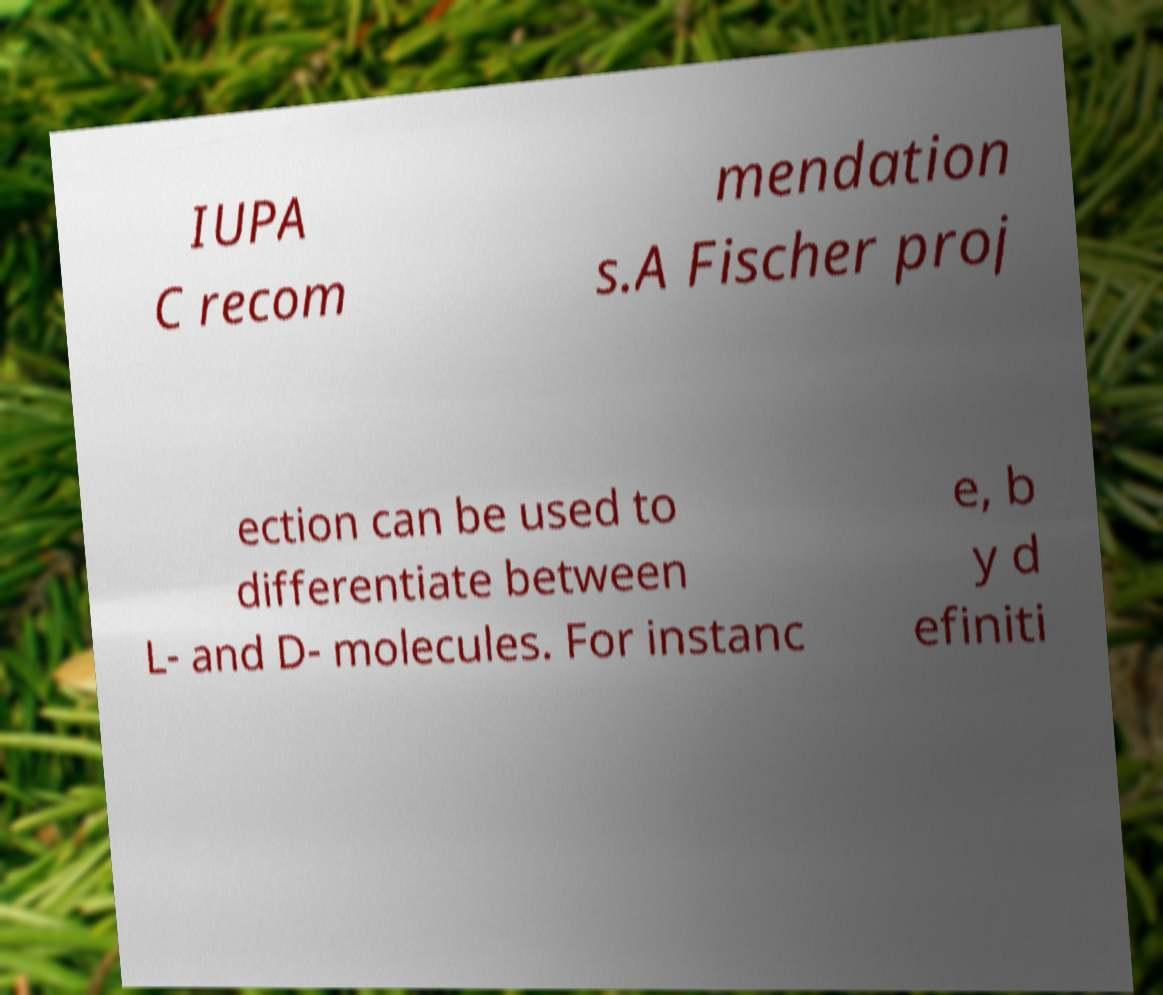Can you read and provide the text displayed in the image?This photo seems to have some interesting text. Can you extract and type it out for me? IUPA C recom mendation s.A Fischer proj ection can be used to differentiate between L- and D- molecules. For instanc e, b y d efiniti 